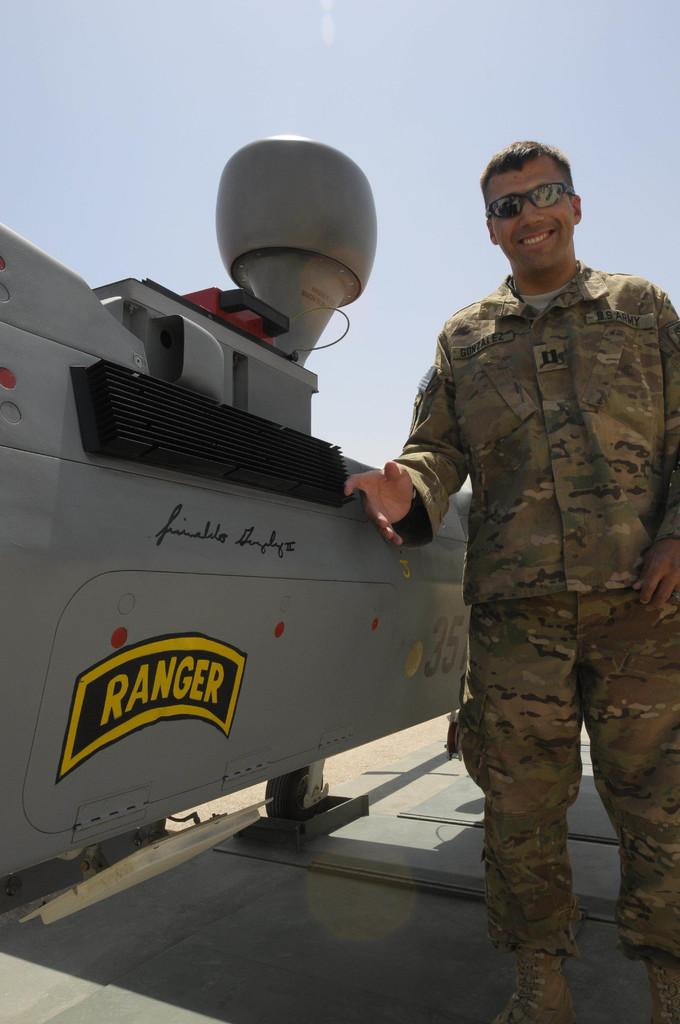What is the main subject of the picture? The main subject of the picture is a man. What is the man doing in the picture? The man is standing in the picture. What is the man's facial expression in the picture? The man is smiling in the picture. What else can be seen in the picture besides the man? There is an object in the picture. What is visible in the background of the picture? The sky is visible in the background of the picture. Can you tell me how many moons are visible in the picture? There are no moons visible in the picture; only the man, an object, and the sky are present. What form does the object in the picture take? The description of the object in the picture does not specify its form, so it cannot be determined from the image. 